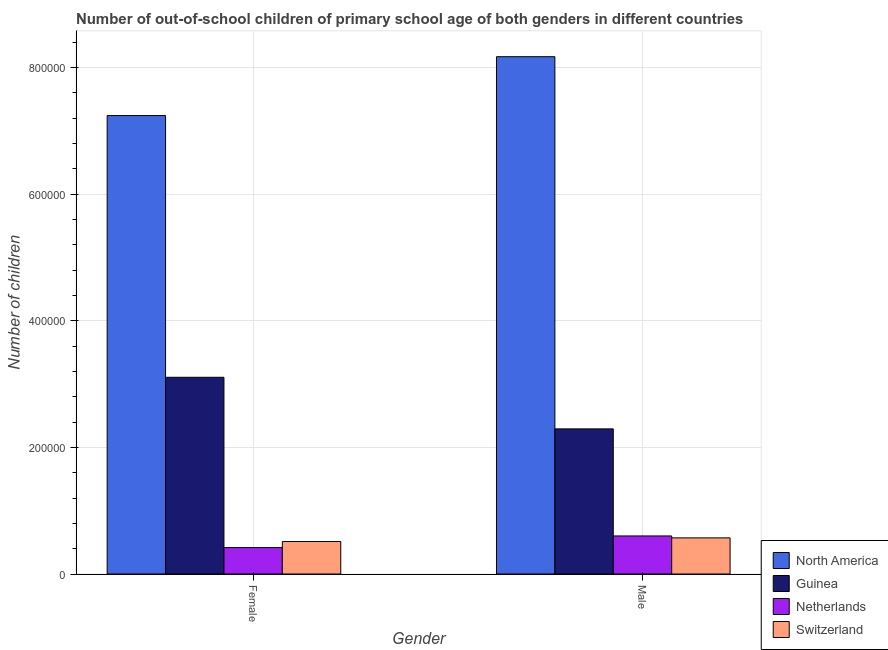How many bars are there on the 2nd tick from the right?
Offer a terse response. 4. What is the number of male out-of-school students in Guinea?
Give a very brief answer. 2.29e+05. Across all countries, what is the maximum number of male out-of-school students?
Provide a short and direct response. 8.17e+05. Across all countries, what is the minimum number of male out-of-school students?
Keep it short and to the point. 5.71e+04. In which country was the number of female out-of-school students maximum?
Offer a terse response. North America. In which country was the number of female out-of-school students minimum?
Provide a succinct answer. Netherlands. What is the total number of female out-of-school students in the graph?
Offer a terse response. 1.13e+06. What is the difference between the number of female out-of-school students in North America and that in Switzerland?
Give a very brief answer. 6.73e+05. What is the difference between the number of male out-of-school students in North America and the number of female out-of-school students in Guinea?
Provide a succinct answer. 5.06e+05. What is the average number of female out-of-school students per country?
Ensure brevity in your answer.  2.82e+05. What is the difference between the number of female out-of-school students and number of male out-of-school students in Guinea?
Your answer should be compact. 8.15e+04. What is the ratio of the number of female out-of-school students in Switzerland to that in North America?
Offer a terse response. 0.07. Is the number of female out-of-school students in Netherlands less than that in Guinea?
Your answer should be very brief. Yes. What does the 2nd bar from the left in Female represents?
Provide a short and direct response. Guinea. What does the 3rd bar from the right in Female represents?
Your response must be concise. Guinea. How many bars are there?
Give a very brief answer. 8. What is the difference between two consecutive major ticks on the Y-axis?
Give a very brief answer. 2.00e+05. Are the values on the major ticks of Y-axis written in scientific E-notation?
Ensure brevity in your answer.  No. Does the graph contain any zero values?
Your answer should be very brief. No. Does the graph contain grids?
Give a very brief answer. Yes. How many legend labels are there?
Keep it short and to the point. 4. How are the legend labels stacked?
Provide a succinct answer. Vertical. What is the title of the graph?
Ensure brevity in your answer.  Number of out-of-school children of primary school age of both genders in different countries. Does "Togo" appear as one of the legend labels in the graph?
Offer a terse response. No. What is the label or title of the Y-axis?
Your response must be concise. Number of children. What is the Number of children in North America in Female?
Offer a terse response. 7.24e+05. What is the Number of children in Guinea in Female?
Offer a very short reply. 3.11e+05. What is the Number of children of Netherlands in Female?
Your response must be concise. 4.18e+04. What is the Number of children of Switzerland in Female?
Your answer should be very brief. 5.13e+04. What is the Number of children in North America in Male?
Give a very brief answer. 8.17e+05. What is the Number of children in Guinea in Male?
Offer a very short reply. 2.29e+05. What is the Number of children in Netherlands in Male?
Provide a short and direct response. 6.01e+04. What is the Number of children of Switzerland in Male?
Provide a succinct answer. 5.71e+04. Across all Gender, what is the maximum Number of children in North America?
Provide a short and direct response. 8.17e+05. Across all Gender, what is the maximum Number of children in Guinea?
Provide a short and direct response. 3.11e+05. Across all Gender, what is the maximum Number of children in Netherlands?
Make the answer very short. 6.01e+04. Across all Gender, what is the maximum Number of children in Switzerland?
Your answer should be very brief. 5.71e+04. Across all Gender, what is the minimum Number of children of North America?
Your answer should be very brief. 7.24e+05. Across all Gender, what is the minimum Number of children in Guinea?
Ensure brevity in your answer.  2.29e+05. Across all Gender, what is the minimum Number of children in Netherlands?
Your response must be concise. 4.18e+04. Across all Gender, what is the minimum Number of children in Switzerland?
Your answer should be compact. 5.13e+04. What is the total Number of children in North America in the graph?
Your answer should be compact. 1.54e+06. What is the total Number of children in Guinea in the graph?
Your answer should be very brief. 5.40e+05. What is the total Number of children of Netherlands in the graph?
Your answer should be compact. 1.02e+05. What is the total Number of children of Switzerland in the graph?
Your response must be concise. 1.08e+05. What is the difference between the Number of children of North America in Female and that in Male?
Your answer should be compact. -9.30e+04. What is the difference between the Number of children of Guinea in Female and that in Male?
Provide a short and direct response. 8.15e+04. What is the difference between the Number of children in Netherlands in Female and that in Male?
Give a very brief answer. -1.84e+04. What is the difference between the Number of children in Switzerland in Female and that in Male?
Provide a short and direct response. -5739. What is the difference between the Number of children in North America in Female and the Number of children in Guinea in Male?
Ensure brevity in your answer.  4.95e+05. What is the difference between the Number of children in North America in Female and the Number of children in Netherlands in Male?
Provide a short and direct response. 6.64e+05. What is the difference between the Number of children in North America in Female and the Number of children in Switzerland in Male?
Your response must be concise. 6.67e+05. What is the difference between the Number of children in Guinea in Female and the Number of children in Netherlands in Male?
Offer a very short reply. 2.51e+05. What is the difference between the Number of children of Guinea in Female and the Number of children of Switzerland in Male?
Your response must be concise. 2.54e+05. What is the difference between the Number of children in Netherlands in Female and the Number of children in Switzerland in Male?
Your answer should be compact. -1.53e+04. What is the average Number of children of North America per Gender?
Give a very brief answer. 7.71e+05. What is the average Number of children in Guinea per Gender?
Offer a terse response. 2.70e+05. What is the average Number of children in Netherlands per Gender?
Provide a short and direct response. 5.09e+04. What is the average Number of children in Switzerland per Gender?
Provide a short and direct response. 5.42e+04. What is the difference between the Number of children of North America and Number of children of Guinea in Female?
Keep it short and to the point. 4.13e+05. What is the difference between the Number of children of North America and Number of children of Netherlands in Female?
Your answer should be very brief. 6.82e+05. What is the difference between the Number of children in North America and Number of children in Switzerland in Female?
Your answer should be very brief. 6.73e+05. What is the difference between the Number of children in Guinea and Number of children in Netherlands in Female?
Your response must be concise. 2.69e+05. What is the difference between the Number of children of Guinea and Number of children of Switzerland in Female?
Offer a very short reply. 2.59e+05. What is the difference between the Number of children in Netherlands and Number of children in Switzerland in Female?
Your answer should be compact. -9568. What is the difference between the Number of children in North America and Number of children in Guinea in Male?
Your response must be concise. 5.88e+05. What is the difference between the Number of children in North America and Number of children in Netherlands in Male?
Your answer should be very brief. 7.57e+05. What is the difference between the Number of children of North America and Number of children of Switzerland in Male?
Your response must be concise. 7.60e+05. What is the difference between the Number of children in Guinea and Number of children in Netherlands in Male?
Make the answer very short. 1.69e+05. What is the difference between the Number of children in Guinea and Number of children in Switzerland in Male?
Provide a succinct answer. 1.72e+05. What is the difference between the Number of children in Netherlands and Number of children in Switzerland in Male?
Make the answer very short. 3051. What is the ratio of the Number of children in North America in Female to that in Male?
Your answer should be compact. 0.89. What is the ratio of the Number of children in Guinea in Female to that in Male?
Provide a short and direct response. 1.36. What is the ratio of the Number of children of Netherlands in Female to that in Male?
Ensure brevity in your answer.  0.69. What is the ratio of the Number of children of Switzerland in Female to that in Male?
Your response must be concise. 0.9. What is the difference between the highest and the second highest Number of children of North America?
Offer a very short reply. 9.30e+04. What is the difference between the highest and the second highest Number of children in Guinea?
Your answer should be very brief. 8.15e+04. What is the difference between the highest and the second highest Number of children of Netherlands?
Ensure brevity in your answer.  1.84e+04. What is the difference between the highest and the second highest Number of children in Switzerland?
Your answer should be compact. 5739. What is the difference between the highest and the lowest Number of children in North America?
Offer a terse response. 9.30e+04. What is the difference between the highest and the lowest Number of children in Guinea?
Ensure brevity in your answer.  8.15e+04. What is the difference between the highest and the lowest Number of children in Netherlands?
Offer a terse response. 1.84e+04. What is the difference between the highest and the lowest Number of children in Switzerland?
Your answer should be very brief. 5739. 